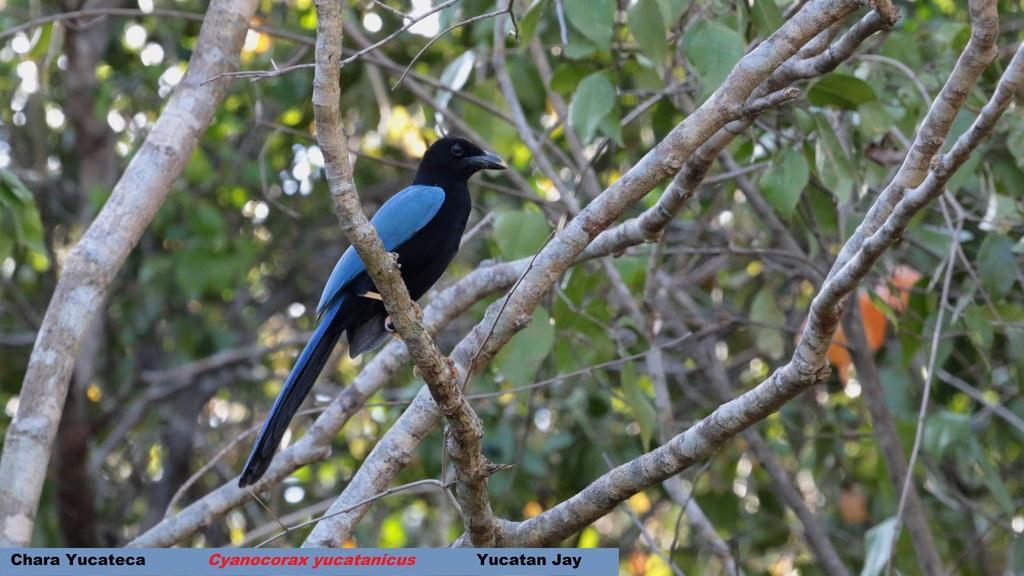Can you describe this image briefly? In this image we can see a bird which is black and blue in color is standing on the stems. In the background of the image we can see leaves and stems but it is in a blur. 